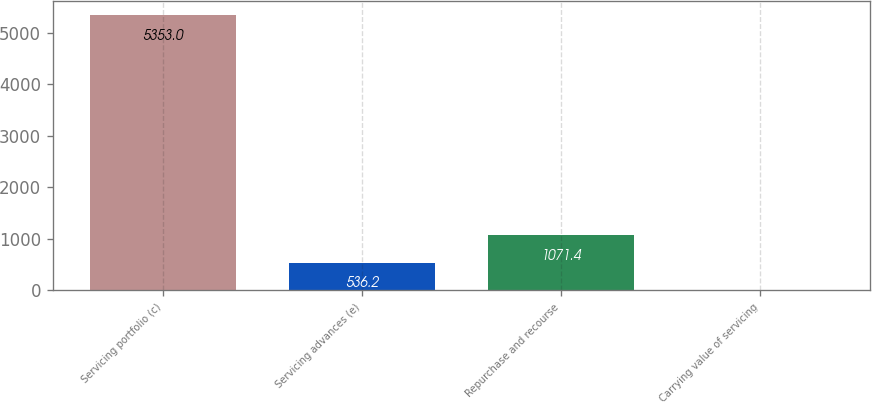Convert chart. <chart><loc_0><loc_0><loc_500><loc_500><bar_chart><fcel>Servicing portfolio (c)<fcel>Servicing advances (e)<fcel>Repurchase and recourse<fcel>Carrying value of servicing<nl><fcel>5353<fcel>536.2<fcel>1071.4<fcel>1<nl></chart> 